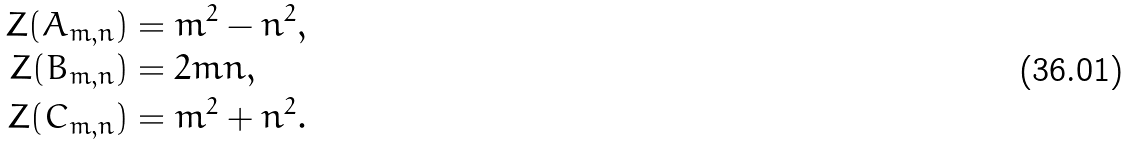<formula> <loc_0><loc_0><loc_500><loc_500>Z ( A _ { m , n } ) & = m ^ { 2 } - n ^ { 2 } , \\ Z ( B _ { m , n } ) & = 2 m n , \\ Z ( C _ { m , n } ) & = m ^ { 2 } + n ^ { 2 } .</formula> 